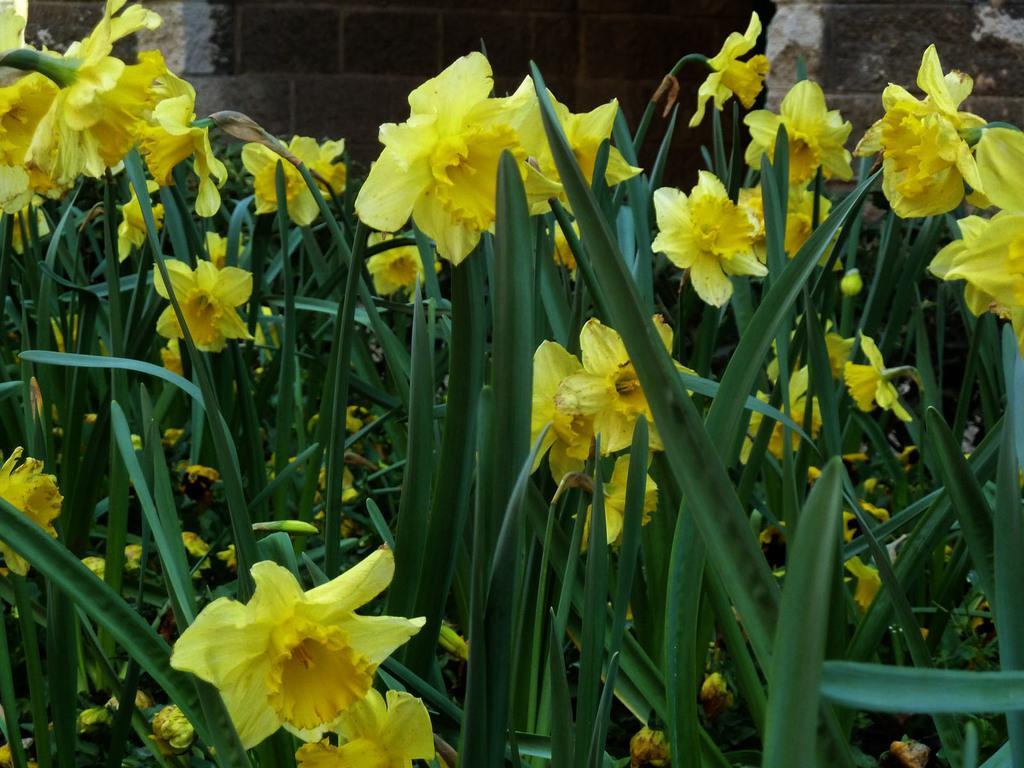How would you summarize this image in a sentence or two? In the foreground I can see the flowering plants. In the background, I can see the wall. 